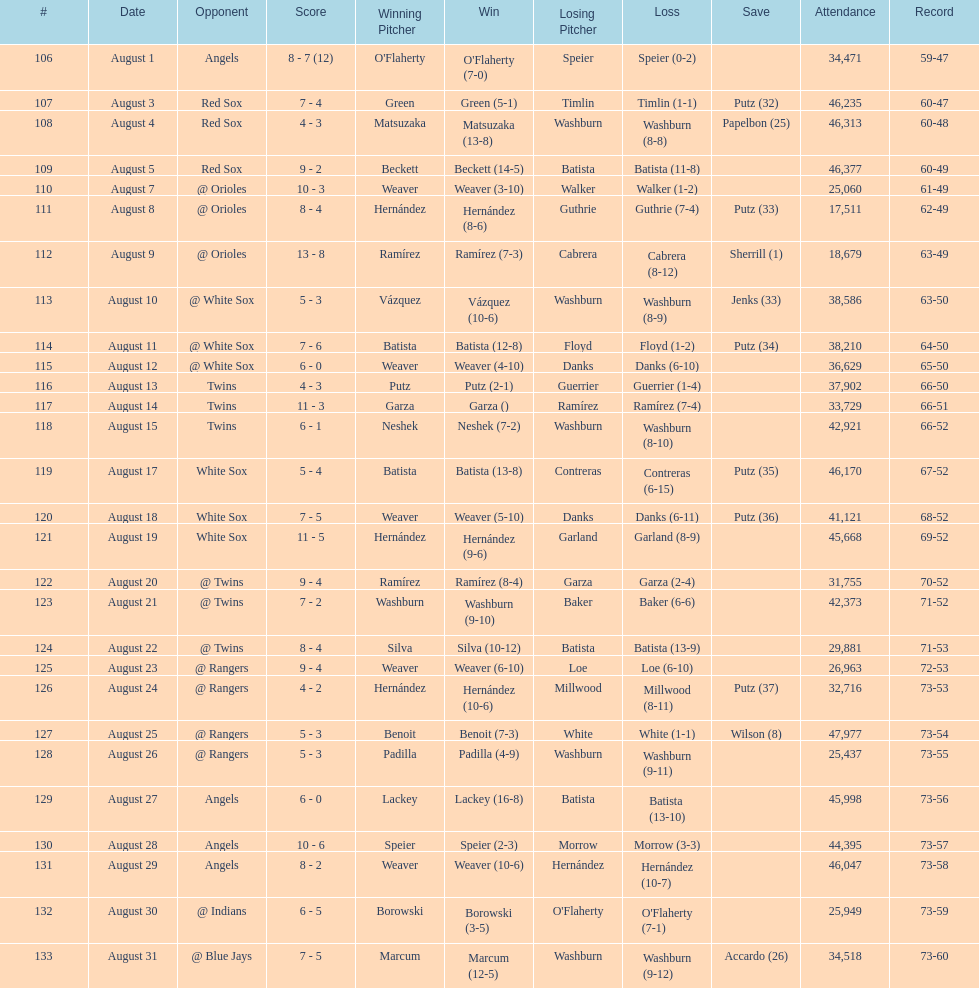Number of wins during stretch 5. 